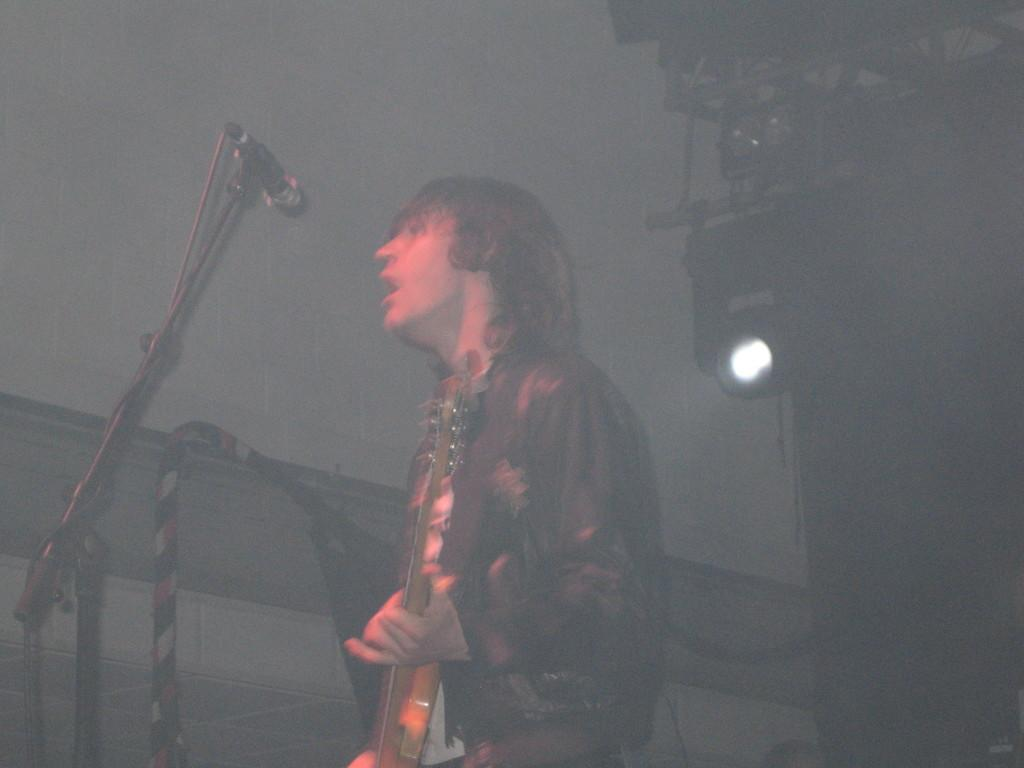Who is the main subject in the image? There is a man in the image. What is the man doing in the image? The man is standing, playing the guitar, and singing into a microphone. What type of cabbage is the man holding in the image? There is no cabbage present in the image; the man is holding a guitar and singing into a microphone. 